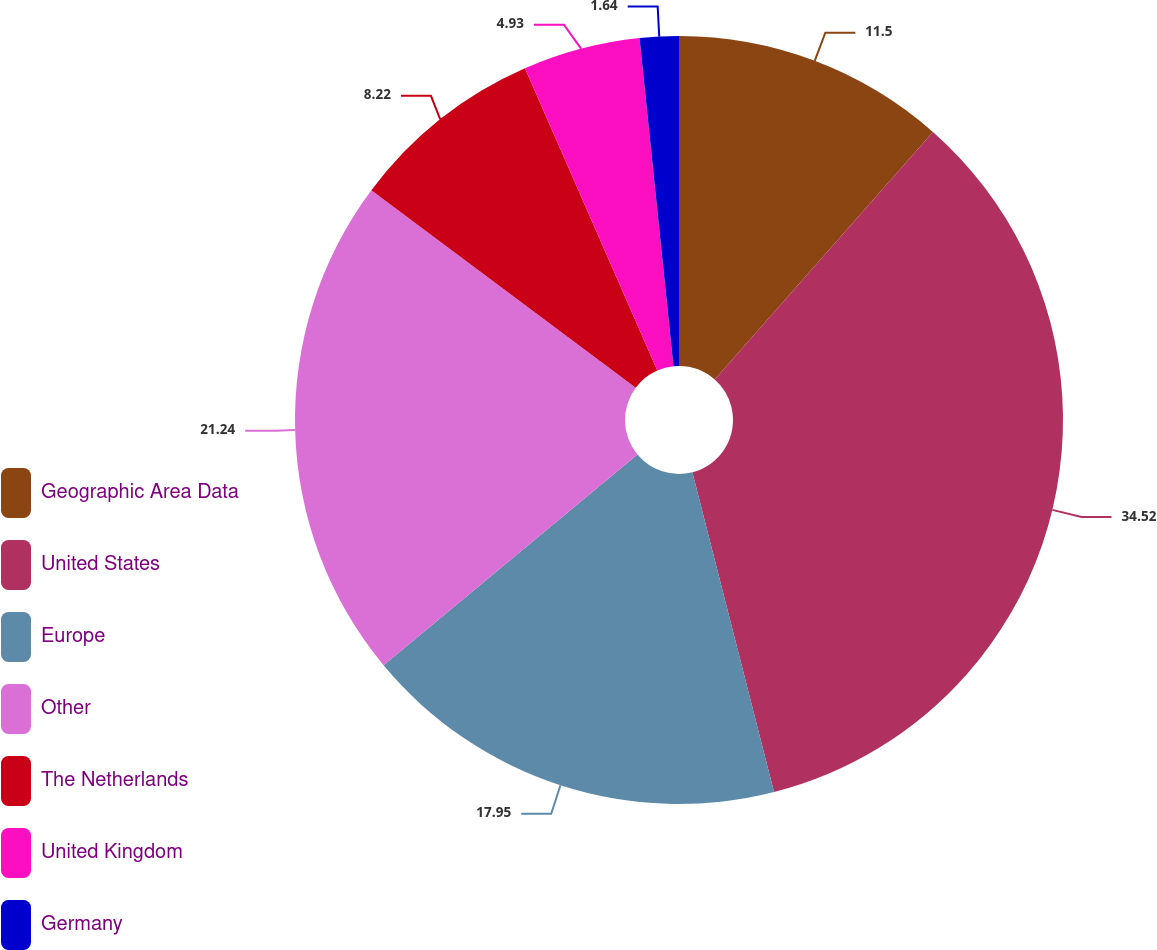<chart> <loc_0><loc_0><loc_500><loc_500><pie_chart><fcel>Geographic Area Data<fcel>United States<fcel>Europe<fcel>Other<fcel>The Netherlands<fcel>United Kingdom<fcel>Germany<nl><fcel>11.5%<fcel>34.52%<fcel>17.95%<fcel>21.24%<fcel>8.22%<fcel>4.93%<fcel>1.64%<nl></chart> 